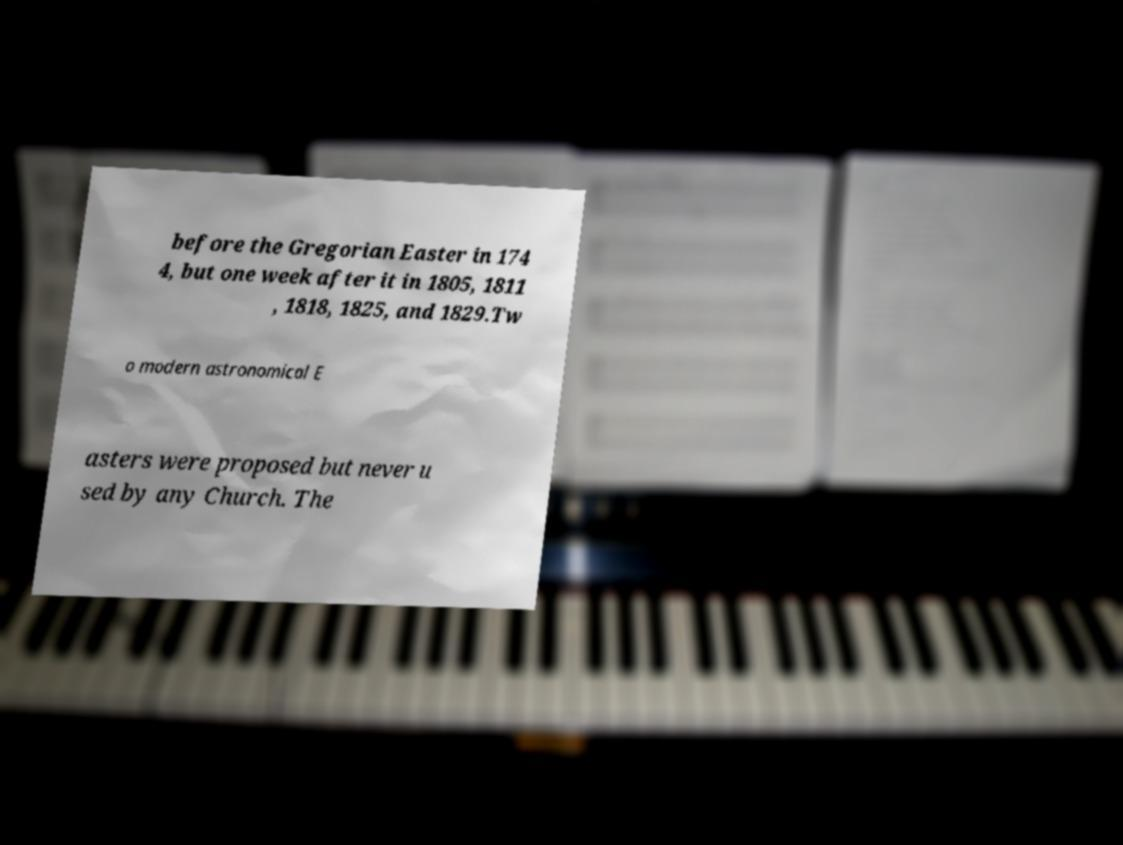Please read and relay the text visible in this image. What does it say? before the Gregorian Easter in 174 4, but one week after it in 1805, 1811 , 1818, 1825, and 1829.Tw o modern astronomical E asters were proposed but never u sed by any Church. The 